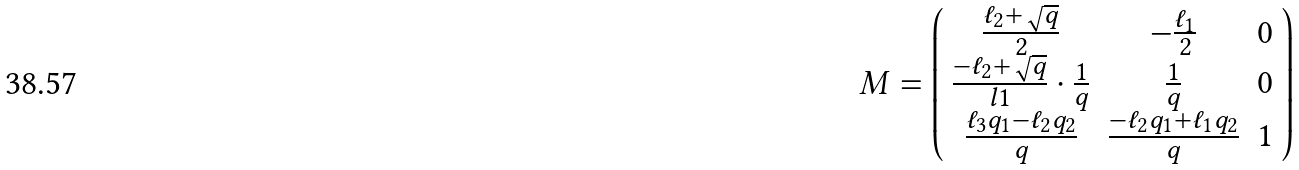Convert formula to latex. <formula><loc_0><loc_0><loc_500><loc_500>M = \left ( \begin{array} { c c c } \frac { \ell _ { 2 } + \sqrt { q } } { 2 } & - \frac { \ell _ { 1 } } { 2 } & 0 \\ \frac { - \ell _ { 2 } + \sqrt { q } } { l 1 } \cdot \frac { 1 } { q } & \frac { 1 } { q } & 0 \\ \frac { \ell _ { 3 } q _ { 1 } - \ell _ { 2 } q _ { 2 } } { q } & \frac { - \ell _ { 2 } q _ { 1 } + \ell _ { 1 } q _ { 2 } } { q } & 1 \end{array} \right )</formula> 